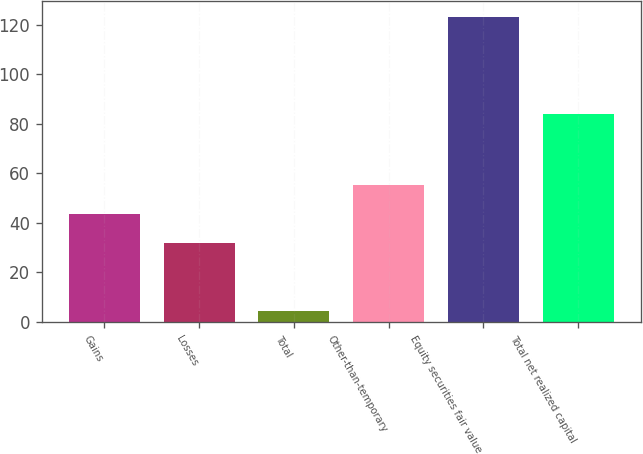Convert chart. <chart><loc_0><loc_0><loc_500><loc_500><bar_chart><fcel>Gains<fcel>Losses<fcel>Total<fcel>Other-than-temporary<fcel>Equity securities fair value<fcel>Total net realized capital<nl><fcel>43.58<fcel>31.7<fcel>4.4<fcel>55.46<fcel>123.2<fcel>84<nl></chart> 